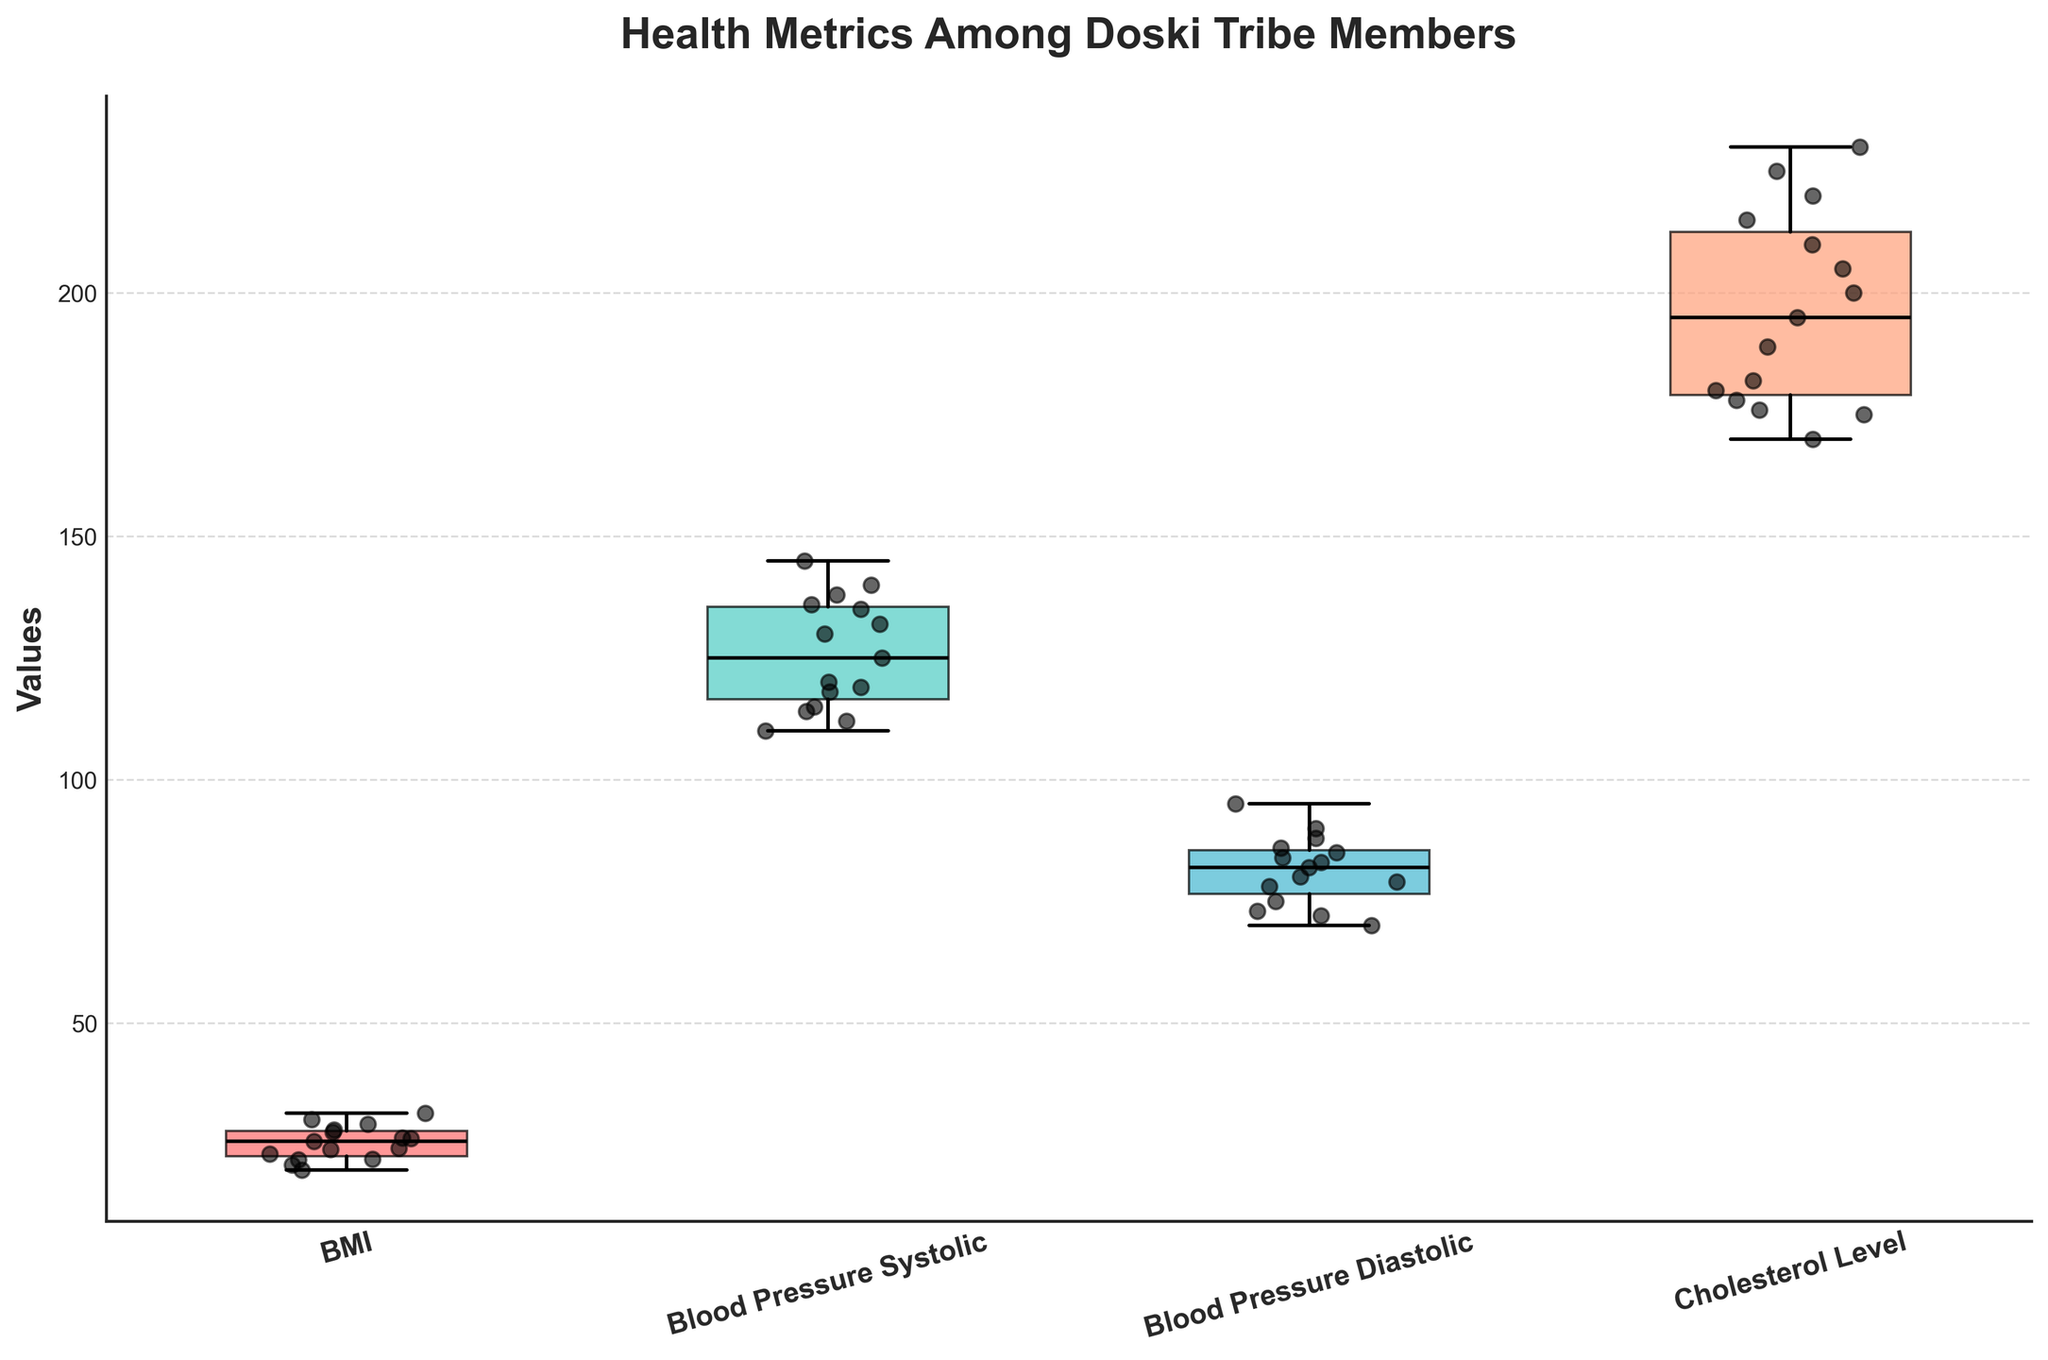What is the range of BMI values shown in the box plot? To find the range, identify the lowest and highest points in the BMI section of the box plot. The whiskers indicate the minimum and maximum values.
Answer: 19.8 to 31.5 What is the median Blood Pressure Systolic value among the tribe members? The median value is shown as a line inside the box. Look at the Systolic Blood Pressure section for the location of this line.
Answer: 125 How many metrics are compared in this figure? Each metric is represented by a separate box plot. Count the number of box plots along the x-axis.
Answer: 4 Which health metric has the highest maximum value? Locate the highest whisker in each of the box plots and compare their positions.
Answer: Cholesterol Level Is the spread of BMI values larger or smaller than the spread of Blood Pressure Diastolic values? Compare the length of the boxes and the distance between the whiskers in the BMI and Diastolic Blood Pressure sections of the box plot.
Answer: Larger Which health metric shows the most outliers? Outliers are represented by scatter points far from the box and whiskers. Count the outliers for each metric.
Answer: BMI What is the average Blood Pressure Diastolic value among the tribe members? To find the average, add all the Blood Pressure Diastolic values and divide by the number of tribe members. ((80 + 70 + 85 + 90 + 75 + 82 + 83 + 78 + 95 + 72 + 79 + 84 + 88) / 15)
Answer: 81.1 How does the 75th percentile of BMI compare to the median BMI? The 75th percentile is the top edge of the box, while the median is the line inside the box. Compare these positions in the BMI section.
Answer: Greater than Are there more female members with high cholesterol levels or male members with high cholesterol levels? High cholesterol levels are found towards the higher end of the Cholesterol Level box plot. Compare the scatter points representing males and females.
Answer: Female What is the cholesterol level for the tribe member with the highest BMI? Find the scatter point representing the highest BMI, and note its corresponding Cholesterol Level value.
Answer: 230 